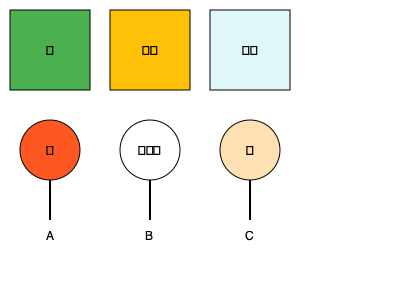Match the endangered species to their natural habitats by selecting the correct combination of letters:

1. Orangutan
2. Polar Bear
3. Fennec Fox To match the endangered species to their natural habitats, let's analyze each species and habitat:

1. Orangutan (🦧):
   - Orangutans are primarily found in tropical rainforests.
   - The rainforest habitat is represented by the green square with a palm tree emoji (🌴).
   - This corresponds to option A.

2. Polar Bear (🐻‍❄️):
   - Polar bears live in the Arctic regions.
   - The Arctic habitat is represented by the light blue square with a snowflake emoji (❄️).
   - This corresponds to option B.

3. Fennec Fox (🦊):
   - Fennec foxes are adapted to live in desert environments.
   - The desert habitat is represented by the yellow square with a desert emoji (🏜️).
   - This corresponds to option C.

Therefore, the correct matching is:
1. Orangutan - A (Rainforest)
2. Polar Bear - B (Arctic)
3. Fennec Fox - C (Desert)
Answer: A, B, C 